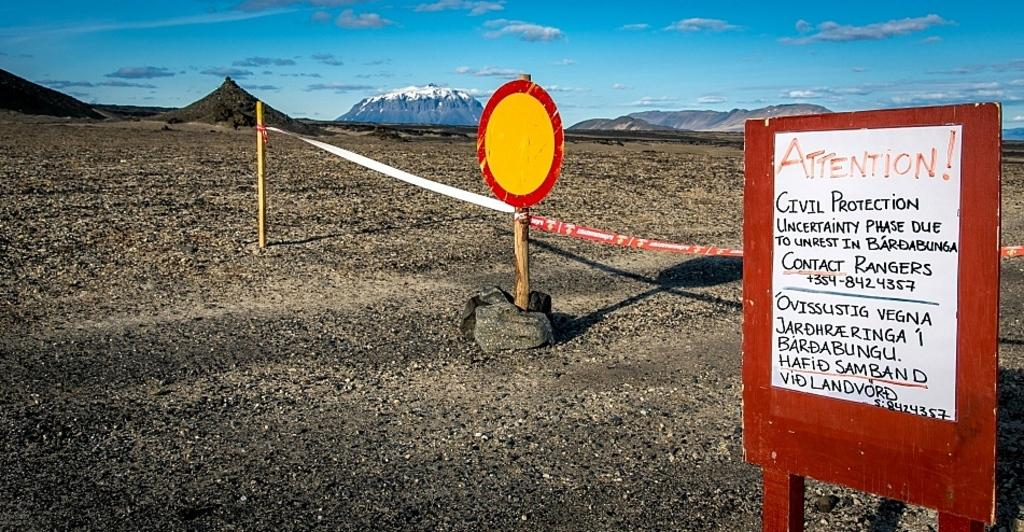<image>
Present a compact description of the photo's key features. A sign outside a mountain range that mentions civil unrest. 